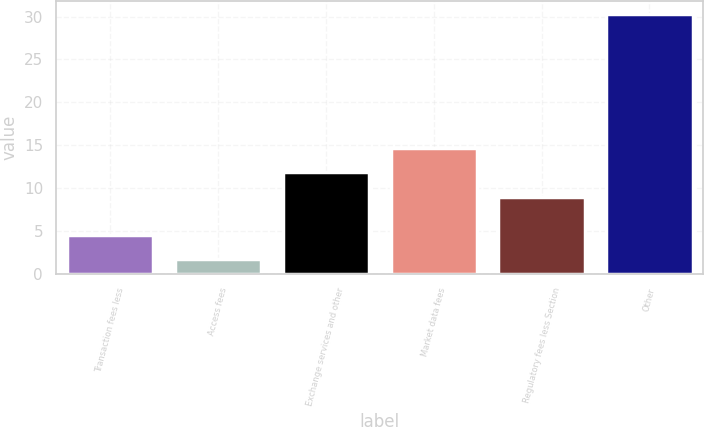<chart> <loc_0><loc_0><loc_500><loc_500><bar_chart><fcel>Transaction fees less<fcel>Access fees<fcel>Exchange services and other<fcel>Market data fees<fcel>Regulatory fees less Section<fcel>Other<nl><fcel>4.56<fcel>1.7<fcel>11.86<fcel>14.72<fcel>9<fcel>30.3<nl></chart> 